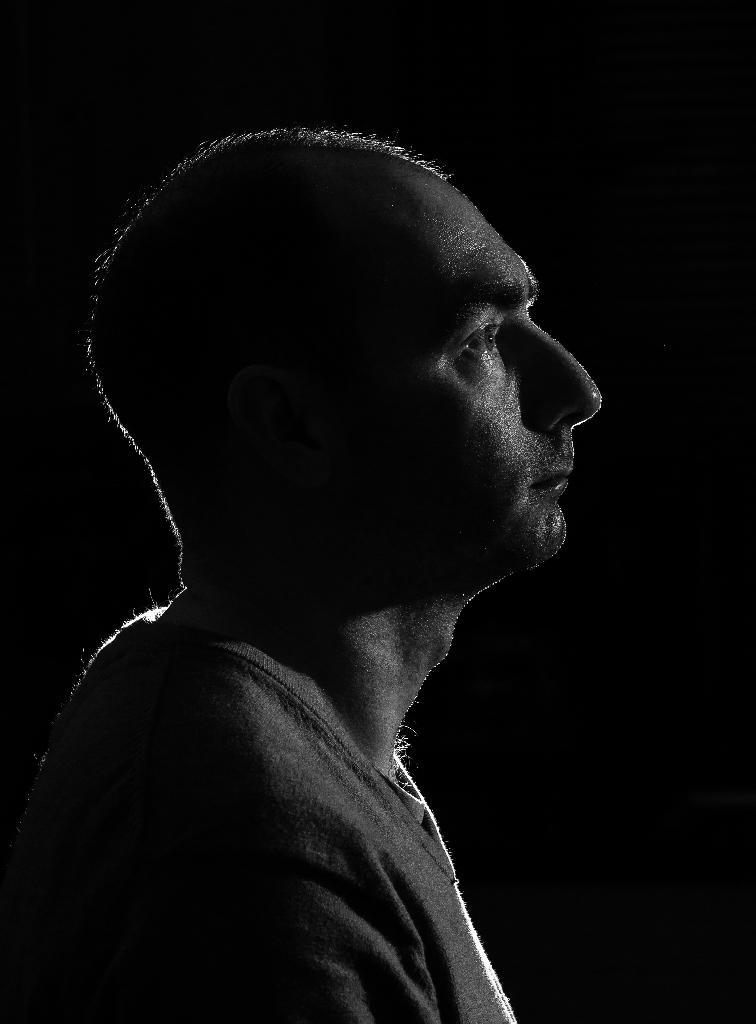What type of picture is in the image? The image contains a black and white picture. What is the subject of the picture? The picture depicts aicts a person. What type of journey does the person in the picture regret? There is no information about a journey or regret in the image, as it only contains a black and white picture of a person. 